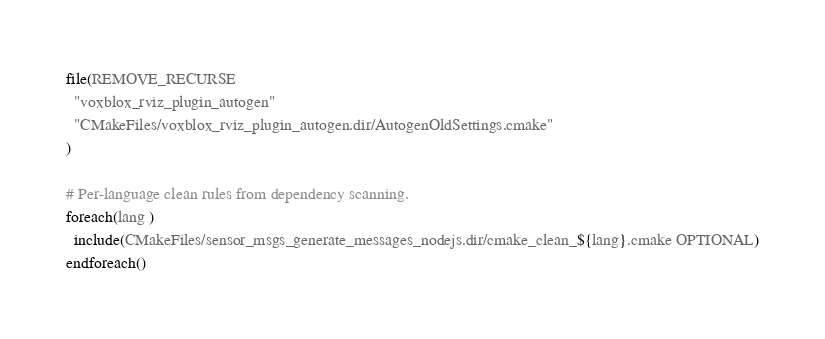Convert code to text. <code><loc_0><loc_0><loc_500><loc_500><_CMake_>file(REMOVE_RECURSE
  "voxblox_rviz_plugin_autogen"
  "CMakeFiles/voxblox_rviz_plugin_autogen.dir/AutogenOldSettings.cmake"
)

# Per-language clean rules from dependency scanning.
foreach(lang )
  include(CMakeFiles/sensor_msgs_generate_messages_nodejs.dir/cmake_clean_${lang}.cmake OPTIONAL)
endforeach()
</code> 